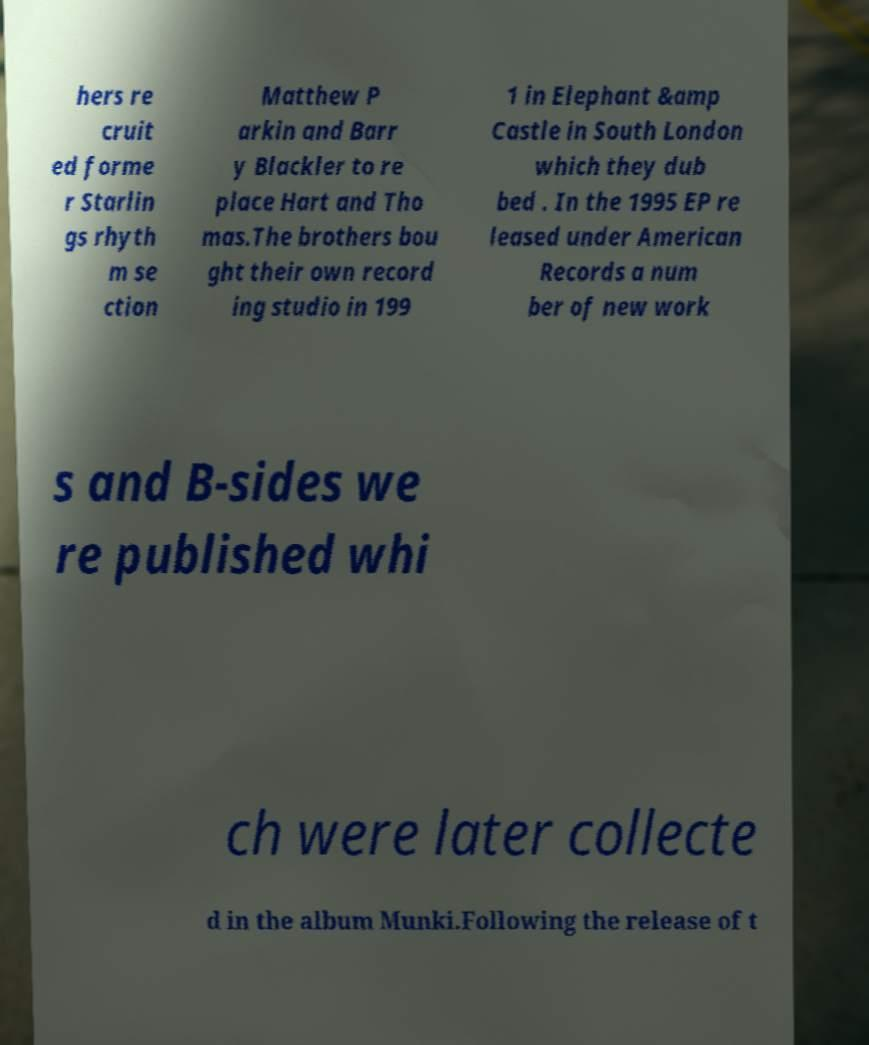Can you accurately transcribe the text from the provided image for me? hers re cruit ed forme r Starlin gs rhyth m se ction Matthew P arkin and Barr y Blackler to re place Hart and Tho mas.The brothers bou ght their own record ing studio in 199 1 in Elephant &amp Castle in South London which they dub bed . In the 1995 EP re leased under American Records a num ber of new work s and B-sides we re published whi ch were later collecte d in the album Munki.Following the release of t 